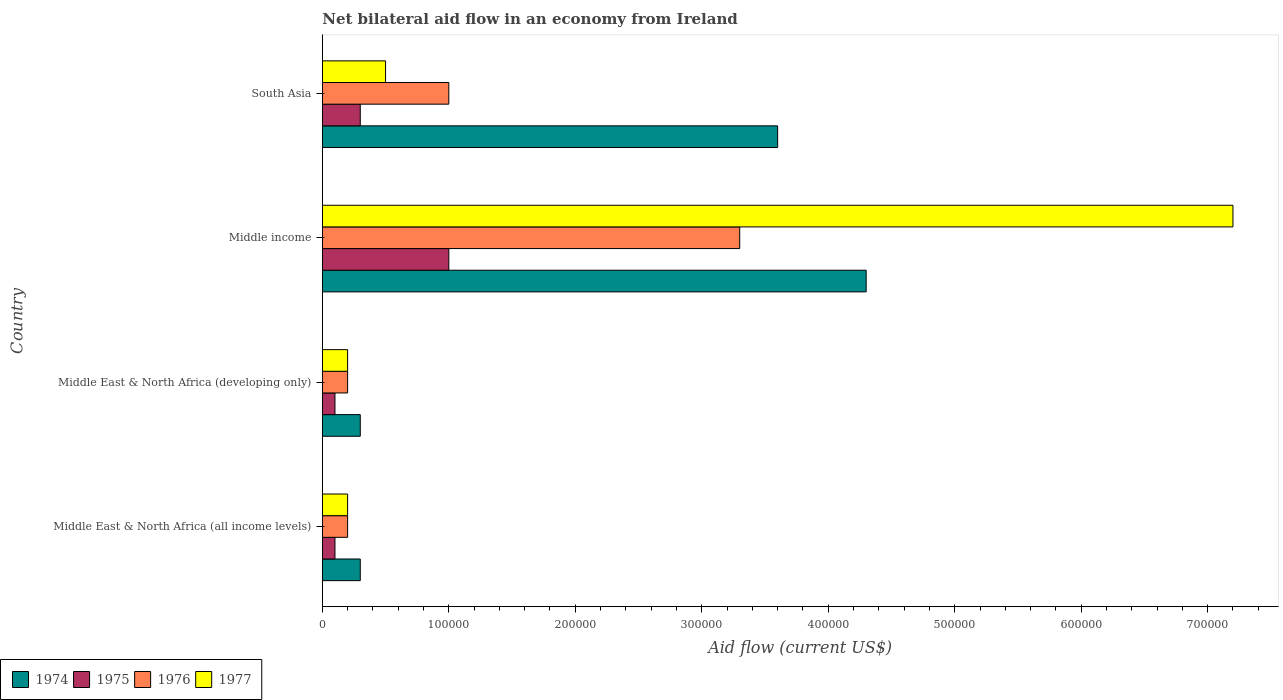How many different coloured bars are there?
Offer a terse response. 4. How many groups of bars are there?
Ensure brevity in your answer.  4. Are the number of bars on each tick of the Y-axis equal?
Keep it short and to the point. Yes. How many bars are there on the 3rd tick from the top?
Provide a succinct answer. 4. What is the label of the 3rd group of bars from the top?
Offer a terse response. Middle East & North Africa (developing only). What is the net bilateral aid flow in 1977 in Middle East & North Africa (all income levels)?
Provide a short and direct response. 2.00e+04. Across all countries, what is the maximum net bilateral aid flow in 1975?
Give a very brief answer. 1.00e+05. In which country was the net bilateral aid flow in 1977 maximum?
Your answer should be compact. Middle income. In which country was the net bilateral aid flow in 1977 minimum?
Your answer should be very brief. Middle East & North Africa (all income levels). What is the total net bilateral aid flow in 1977 in the graph?
Make the answer very short. 8.10e+05. What is the difference between the net bilateral aid flow in 1975 in Middle income and that in South Asia?
Keep it short and to the point. 7.00e+04. What is the difference between the net bilateral aid flow in 1974 in South Asia and the net bilateral aid flow in 1975 in Middle East & North Africa (all income levels)?
Give a very brief answer. 3.50e+05. What is the average net bilateral aid flow in 1974 per country?
Your answer should be very brief. 2.12e+05. What is the difference between the net bilateral aid flow in 1976 and net bilateral aid flow in 1977 in South Asia?
Keep it short and to the point. 5.00e+04. In how many countries, is the net bilateral aid flow in 1975 greater than 700000 US$?
Provide a succinct answer. 0. What is the difference between the highest and the second highest net bilateral aid flow in 1977?
Provide a succinct answer. 6.70e+05. What is the difference between the highest and the lowest net bilateral aid flow in 1974?
Provide a succinct answer. 4.00e+05. Is the sum of the net bilateral aid flow in 1977 in Middle East & North Africa (developing only) and South Asia greater than the maximum net bilateral aid flow in 1976 across all countries?
Keep it short and to the point. No. Is it the case that in every country, the sum of the net bilateral aid flow in 1977 and net bilateral aid flow in 1976 is greater than the sum of net bilateral aid flow in 1974 and net bilateral aid flow in 1975?
Provide a short and direct response. No. What does the 4th bar from the top in Middle income represents?
Make the answer very short. 1974. What does the 4th bar from the bottom in Middle East & North Africa (developing only) represents?
Your answer should be compact. 1977. Is it the case that in every country, the sum of the net bilateral aid flow in 1974 and net bilateral aid flow in 1975 is greater than the net bilateral aid flow in 1977?
Your response must be concise. No. How many bars are there?
Give a very brief answer. 16. Are all the bars in the graph horizontal?
Keep it short and to the point. Yes. Does the graph contain grids?
Your answer should be very brief. No. Where does the legend appear in the graph?
Your answer should be very brief. Bottom left. How are the legend labels stacked?
Your answer should be compact. Horizontal. What is the title of the graph?
Your answer should be compact. Net bilateral aid flow in an economy from Ireland. Does "1973" appear as one of the legend labels in the graph?
Provide a succinct answer. No. What is the Aid flow (current US$) in 1974 in Middle East & North Africa (all income levels)?
Keep it short and to the point. 3.00e+04. What is the Aid flow (current US$) in 1976 in Middle East & North Africa (all income levels)?
Give a very brief answer. 2.00e+04. What is the Aid flow (current US$) in 1977 in Middle East & North Africa (all income levels)?
Keep it short and to the point. 2.00e+04. What is the Aid flow (current US$) in 1974 in Middle East & North Africa (developing only)?
Offer a terse response. 3.00e+04. What is the Aid flow (current US$) in 1975 in Middle East & North Africa (developing only)?
Give a very brief answer. 10000. What is the Aid flow (current US$) in 1976 in Middle East & North Africa (developing only)?
Offer a very short reply. 2.00e+04. What is the Aid flow (current US$) of 1977 in Middle East & North Africa (developing only)?
Offer a very short reply. 2.00e+04. What is the Aid flow (current US$) in 1975 in Middle income?
Make the answer very short. 1.00e+05. What is the Aid flow (current US$) of 1977 in Middle income?
Ensure brevity in your answer.  7.20e+05. Across all countries, what is the maximum Aid flow (current US$) of 1974?
Ensure brevity in your answer.  4.30e+05. Across all countries, what is the maximum Aid flow (current US$) in 1976?
Your answer should be very brief. 3.30e+05. Across all countries, what is the maximum Aid flow (current US$) of 1977?
Your answer should be compact. 7.20e+05. Across all countries, what is the minimum Aid flow (current US$) of 1977?
Your response must be concise. 2.00e+04. What is the total Aid flow (current US$) of 1974 in the graph?
Your answer should be very brief. 8.50e+05. What is the total Aid flow (current US$) in 1976 in the graph?
Provide a short and direct response. 4.70e+05. What is the total Aid flow (current US$) in 1977 in the graph?
Ensure brevity in your answer.  8.10e+05. What is the difference between the Aid flow (current US$) of 1977 in Middle East & North Africa (all income levels) and that in Middle East & North Africa (developing only)?
Offer a terse response. 0. What is the difference between the Aid flow (current US$) of 1974 in Middle East & North Africa (all income levels) and that in Middle income?
Offer a very short reply. -4.00e+05. What is the difference between the Aid flow (current US$) in 1976 in Middle East & North Africa (all income levels) and that in Middle income?
Your response must be concise. -3.10e+05. What is the difference between the Aid flow (current US$) in 1977 in Middle East & North Africa (all income levels) and that in Middle income?
Offer a very short reply. -7.00e+05. What is the difference between the Aid flow (current US$) in 1974 in Middle East & North Africa (all income levels) and that in South Asia?
Your answer should be very brief. -3.30e+05. What is the difference between the Aid flow (current US$) of 1975 in Middle East & North Africa (all income levels) and that in South Asia?
Offer a terse response. -2.00e+04. What is the difference between the Aid flow (current US$) in 1976 in Middle East & North Africa (all income levels) and that in South Asia?
Your response must be concise. -8.00e+04. What is the difference between the Aid flow (current US$) of 1974 in Middle East & North Africa (developing only) and that in Middle income?
Your answer should be very brief. -4.00e+05. What is the difference between the Aid flow (current US$) in 1975 in Middle East & North Africa (developing only) and that in Middle income?
Your answer should be compact. -9.00e+04. What is the difference between the Aid flow (current US$) in 1976 in Middle East & North Africa (developing only) and that in Middle income?
Your response must be concise. -3.10e+05. What is the difference between the Aid flow (current US$) in 1977 in Middle East & North Africa (developing only) and that in Middle income?
Make the answer very short. -7.00e+05. What is the difference between the Aid flow (current US$) in 1974 in Middle East & North Africa (developing only) and that in South Asia?
Offer a very short reply. -3.30e+05. What is the difference between the Aid flow (current US$) of 1975 in Middle East & North Africa (developing only) and that in South Asia?
Provide a short and direct response. -2.00e+04. What is the difference between the Aid flow (current US$) in 1977 in Middle East & North Africa (developing only) and that in South Asia?
Provide a succinct answer. -3.00e+04. What is the difference between the Aid flow (current US$) in 1975 in Middle income and that in South Asia?
Keep it short and to the point. 7.00e+04. What is the difference between the Aid flow (current US$) of 1977 in Middle income and that in South Asia?
Make the answer very short. 6.70e+05. What is the difference between the Aid flow (current US$) in 1974 in Middle East & North Africa (all income levels) and the Aid flow (current US$) in 1975 in Middle East & North Africa (developing only)?
Your response must be concise. 2.00e+04. What is the difference between the Aid flow (current US$) in 1974 in Middle East & North Africa (all income levels) and the Aid flow (current US$) in 1976 in Middle East & North Africa (developing only)?
Offer a very short reply. 10000. What is the difference between the Aid flow (current US$) in 1974 in Middle East & North Africa (all income levels) and the Aid flow (current US$) in 1977 in Middle East & North Africa (developing only)?
Your response must be concise. 10000. What is the difference between the Aid flow (current US$) in 1975 in Middle East & North Africa (all income levels) and the Aid flow (current US$) in 1977 in Middle East & North Africa (developing only)?
Offer a very short reply. -10000. What is the difference between the Aid flow (current US$) in 1976 in Middle East & North Africa (all income levels) and the Aid flow (current US$) in 1977 in Middle East & North Africa (developing only)?
Ensure brevity in your answer.  0. What is the difference between the Aid flow (current US$) in 1974 in Middle East & North Africa (all income levels) and the Aid flow (current US$) in 1976 in Middle income?
Offer a terse response. -3.00e+05. What is the difference between the Aid flow (current US$) in 1974 in Middle East & North Africa (all income levels) and the Aid flow (current US$) in 1977 in Middle income?
Keep it short and to the point. -6.90e+05. What is the difference between the Aid flow (current US$) of 1975 in Middle East & North Africa (all income levels) and the Aid flow (current US$) of 1976 in Middle income?
Your response must be concise. -3.20e+05. What is the difference between the Aid flow (current US$) in 1975 in Middle East & North Africa (all income levels) and the Aid flow (current US$) in 1977 in Middle income?
Give a very brief answer. -7.10e+05. What is the difference between the Aid flow (current US$) of 1976 in Middle East & North Africa (all income levels) and the Aid flow (current US$) of 1977 in Middle income?
Give a very brief answer. -7.00e+05. What is the difference between the Aid flow (current US$) of 1974 in Middle East & North Africa (all income levels) and the Aid flow (current US$) of 1975 in South Asia?
Make the answer very short. 0. What is the difference between the Aid flow (current US$) of 1974 in Middle East & North Africa (all income levels) and the Aid flow (current US$) of 1976 in South Asia?
Offer a terse response. -7.00e+04. What is the difference between the Aid flow (current US$) in 1975 in Middle East & North Africa (all income levels) and the Aid flow (current US$) in 1976 in South Asia?
Keep it short and to the point. -9.00e+04. What is the difference between the Aid flow (current US$) of 1976 in Middle East & North Africa (all income levels) and the Aid flow (current US$) of 1977 in South Asia?
Provide a succinct answer. -3.00e+04. What is the difference between the Aid flow (current US$) in 1974 in Middle East & North Africa (developing only) and the Aid flow (current US$) in 1977 in Middle income?
Keep it short and to the point. -6.90e+05. What is the difference between the Aid flow (current US$) in 1975 in Middle East & North Africa (developing only) and the Aid flow (current US$) in 1976 in Middle income?
Your answer should be compact. -3.20e+05. What is the difference between the Aid flow (current US$) in 1975 in Middle East & North Africa (developing only) and the Aid flow (current US$) in 1977 in Middle income?
Provide a short and direct response. -7.10e+05. What is the difference between the Aid flow (current US$) in 1976 in Middle East & North Africa (developing only) and the Aid flow (current US$) in 1977 in Middle income?
Keep it short and to the point. -7.00e+05. What is the difference between the Aid flow (current US$) of 1974 in Middle East & North Africa (developing only) and the Aid flow (current US$) of 1975 in South Asia?
Your response must be concise. 0. What is the difference between the Aid flow (current US$) in 1975 in Middle East & North Africa (developing only) and the Aid flow (current US$) in 1976 in South Asia?
Provide a short and direct response. -9.00e+04. What is the difference between the Aid flow (current US$) in 1974 in Middle income and the Aid flow (current US$) in 1975 in South Asia?
Offer a very short reply. 4.00e+05. What is the difference between the Aid flow (current US$) of 1974 in Middle income and the Aid flow (current US$) of 1976 in South Asia?
Ensure brevity in your answer.  3.30e+05. What is the difference between the Aid flow (current US$) of 1974 in Middle income and the Aid flow (current US$) of 1977 in South Asia?
Provide a succinct answer. 3.80e+05. What is the difference between the Aid flow (current US$) of 1975 in Middle income and the Aid flow (current US$) of 1977 in South Asia?
Ensure brevity in your answer.  5.00e+04. What is the average Aid flow (current US$) of 1974 per country?
Keep it short and to the point. 2.12e+05. What is the average Aid flow (current US$) in 1975 per country?
Make the answer very short. 3.75e+04. What is the average Aid flow (current US$) of 1976 per country?
Make the answer very short. 1.18e+05. What is the average Aid flow (current US$) in 1977 per country?
Give a very brief answer. 2.02e+05. What is the difference between the Aid flow (current US$) in 1974 and Aid flow (current US$) in 1975 in Middle East & North Africa (all income levels)?
Provide a succinct answer. 2.00e+04. What is the difference between the Aid flow (current US$) in 1974 and Aid flow (current US$) in 1976 in Middle East & North Africa (all income levels)?
Keep it short and to the point. 10000. What is the difference between the Aid flow (current US$) in 1974 and Aid flow (current US$) in 1977 in Middle East & North Africa (all income levels)?
Your answer should be compact. 10000. What is the difference between the Aid flow (current US$) of 1975 and Aid flow (current US$) of 1976 in Middle East & North Africa (all income levels)?
Offer a very short reply. -10000. What is the difference between the Aid flow (current US$) of 1974 and Aid flow (current US$) of 1976 in Middle East & North Africa (developing only)?
Offer a very short reply. 10000. What is the difference between the Aid flow (current US$) of 1975 and Aid flow (current US$) of 1976 in Middle East & North Africa (developing only)?
Give a very brief answer. -10000. What is the difference between the Aid flow (current US$) of 1974 and Aid flow (current US$) of 1977 in Middle income?
Provide a short and direct response. -2.90e+05. What is the difference between the Aid flow (current US$) of 1975 and Aid flow (current US$) of 1976 in Middle income?
Keep it short and to the point. -2.30e+05. What is the difference between the Aid flow (current US$) in 1975 and Aid flow (current US$) in 1977 in Middle income?
Your answer should be very brief. -6.20e+05. What is the difference between the Aid flow (current US$) of 1976 and Aid flow (current US$) of 1977 in Middle income?
Your answer should be compact. -3.90e+05. What is the difference between the Aid flow (current US$) in 1974 and Aid flow (current US$) in 1975 in South Asia?
Make the answer very short. 3.30e+05. What is the difference between the Aid flow (current US$) in 1974 and Aid flow (current US$) in 1976 in South Asia?
Your response must be concise. 2.60e+05. What is the difference between the Aid flow (current US$) in 1975 and Aid flow (current US$) in 1976 in South Asia?
Keep it short and to the point. -7.00e+04. What is the difference between the Aid flow (current US$) of 1976 and Aid flow (current US$) of 1977 in South Asia?
Your answer should be very brief. 5.00e+04. What is the ratio of the Aid flow (current US$) in 1974 in Middle East & North Africa (all income levels) to that in Middle East & North Africa (developing only)?
Your response must be concise. 1. What is the ratio of the Aid flow (current US$) of 1975 in Middle East & North Africa (all income levels) to that in Middle East & North Africa (developing only)?
Your answer should be very brief. 1. What is the ratio of the Aid flow (current US$) in 1977 in Middle East & North Africa (all income levels) to that in Middle East & North Africa (developing only)?
Provide a short and direct response. 1. What is the ratio of the Aid flow (current US$) of 1974 in Middle East & North Africa (all income levels) to that in Middle income?
Your answer should be compact. 0.07. What is the ratio of the Aid flow (current US$) in 1975 in Middle East & North Africa (all income levels) to that in Middle income?
Give a very brief answer. 0.1. What is the ratio of the Aid flow (current US$) in 1976 in Middle East & North Africa (all income levels) to that in Middle income?
Provide a succinct answer. 0.06. What is the ratio of the Aid flow (current US$) in 1977 in Middle East & North Africa (all income levels) to that in Middle income?
Offer a very short reply. 0.03. What is the ratio of the Aid flow (current US$) in 1974 in Middle East & North Africa (all income levels) to that in South Asia?
Make the answer very short. 0.08. What is the ratio of the Aid flow (current US$) of 1975 in Middle East & North Africa (all income levels) to that in South Asia?
Your response must be concise. 0.33. What is the ratio of the Aid flow (current US$) of 1977 in Middle East & North Africa (all income levels) to that in South Asia?
Keep it short and to the point. 0.4. What is the ratio of the Aid flow (current US$) of 1974 in Middle East & North Africa (developing only) to that in Middle income?
Ensure brevity in your answer.  0.07. What is the ratio of the Aid flow (current US$) of 1976 in Middle East & North Africa (developing only) to that in Middle income?
Your answer should be very brief. 0.06. What is the ratio of the Aid flow (current US$) of 1977 in Middle East & North Africa (developing only) to that in Middle income?
Your answer should be compact. 0.03. What is the ratio of the Aid flow (current US$) of 1974 in Middle East & North Africa (developing only) to that in South Asia?
Provide a succinct answer. 0.08. What is the ratio of the Aid flow (current US$) of 1974 in Middle income to that in South Asia?
Ensure brevity in your answer.  1.19. What is the ratio of the Aid flow (current US$) in 1975 in Middle income to that in South Asia?
Make the answer very short. 3.33. What is the ratio of the Aid flow (current US$) in 1976 in Middle income to that in South Asia?
Offer a very short reply. 3.3. What is the ratio of the Aid flow (current US$) of 1977 in Middle income to that in South Asia?
Provide a succinct answer. 14.4. What is the difference between the highest and the second highest Aid flow (current US$) in 1976?
Your answer should be very brief. 2.30e+05. What is the difference between the highest and the second highest Aid flow (current US$) of 1977?
Offer a terse response. 6.70e+05. What is the difference between the highest and the lowest Aid flow (current US$) in 1974?
Your answer should be compact. 4.00e+05. 